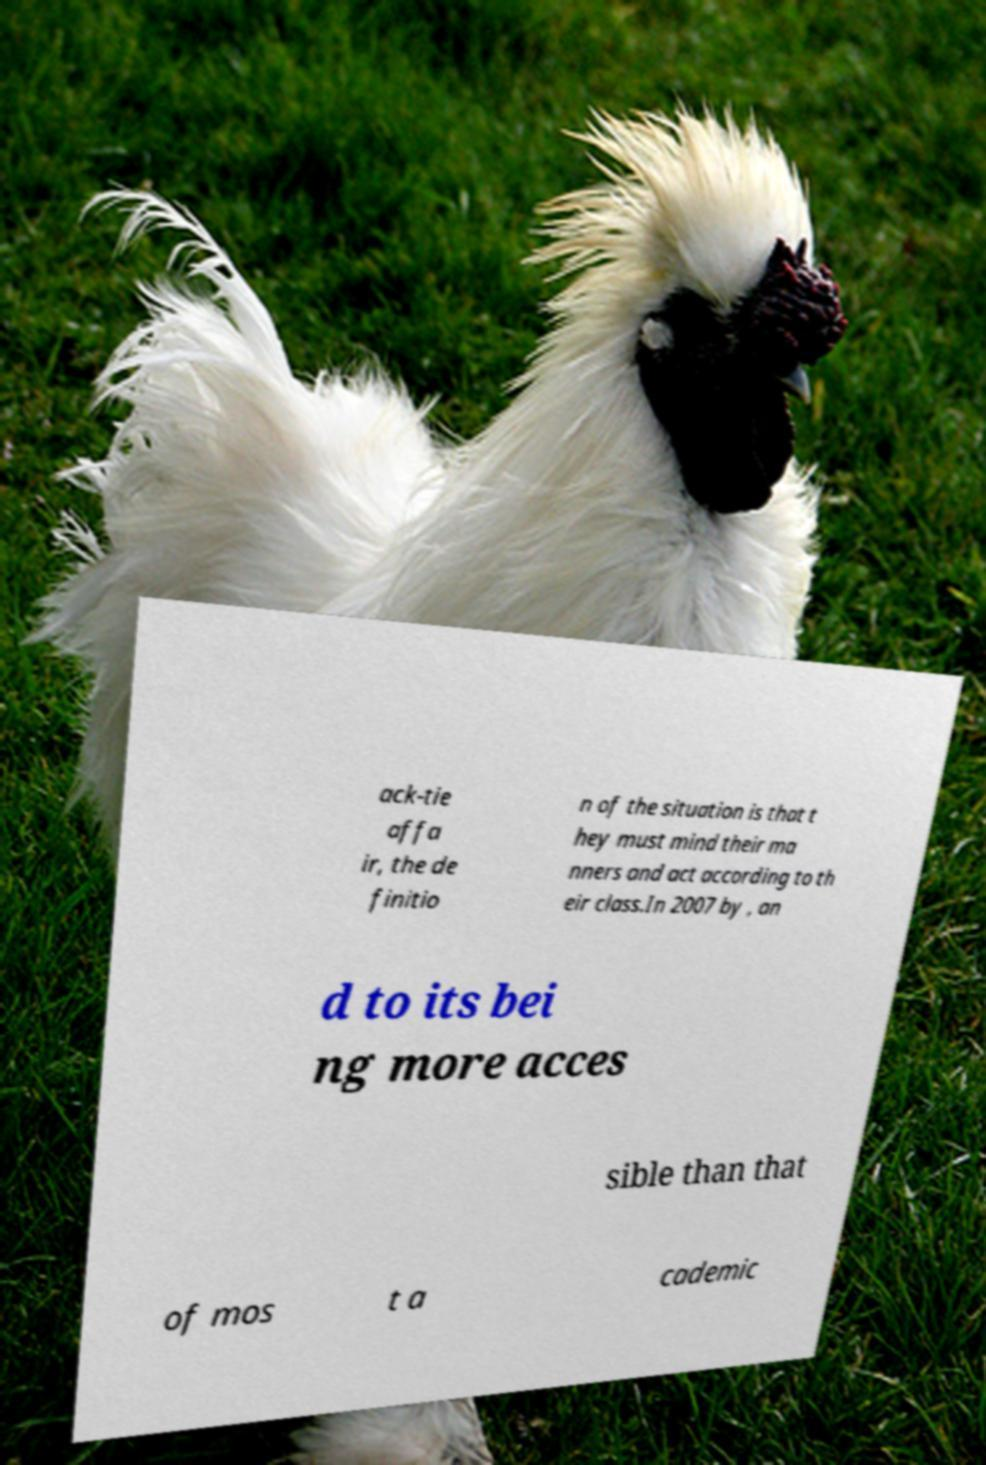Please identify and transcribe the text found in this image. ack-tie affa ir, the de finitio n of the situation is that t hey must mind their ma nners and act according to th eir class.In 2007 by , an d to its bei ng more acces sible than that of mos t a cademic 